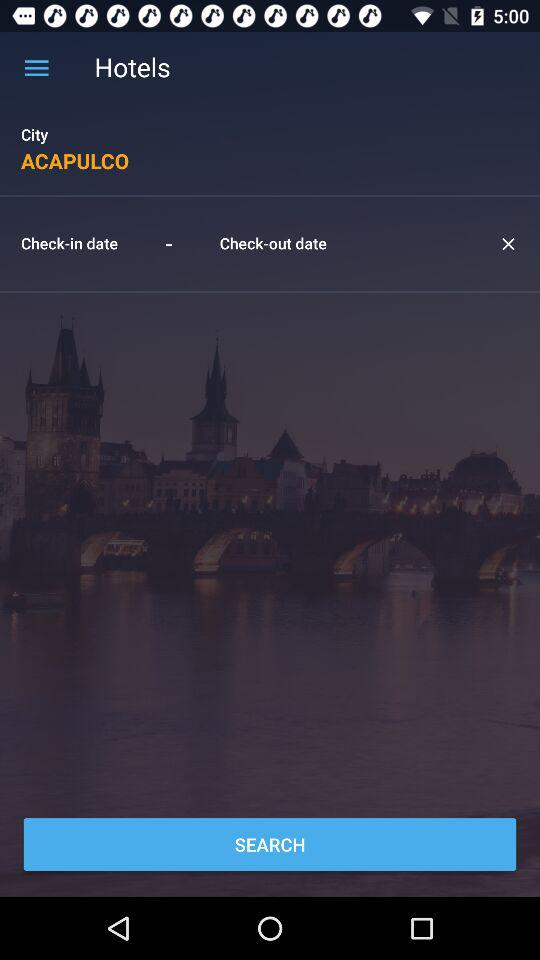What is the city name? The city name is Acapulco. 